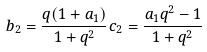Convert formula to latex. <formula><loc_0><loc_0><loc_500><loc_500>b _ { 2 } = \frac { q ( 1 + a _ { 1 } ) } { 1 + q ^ { 2 } } c _ { 2 } = \frac { a _ { 1 } q ^ { 2 } - 1 } { 1 + q ^ { 2 } }</formula> 